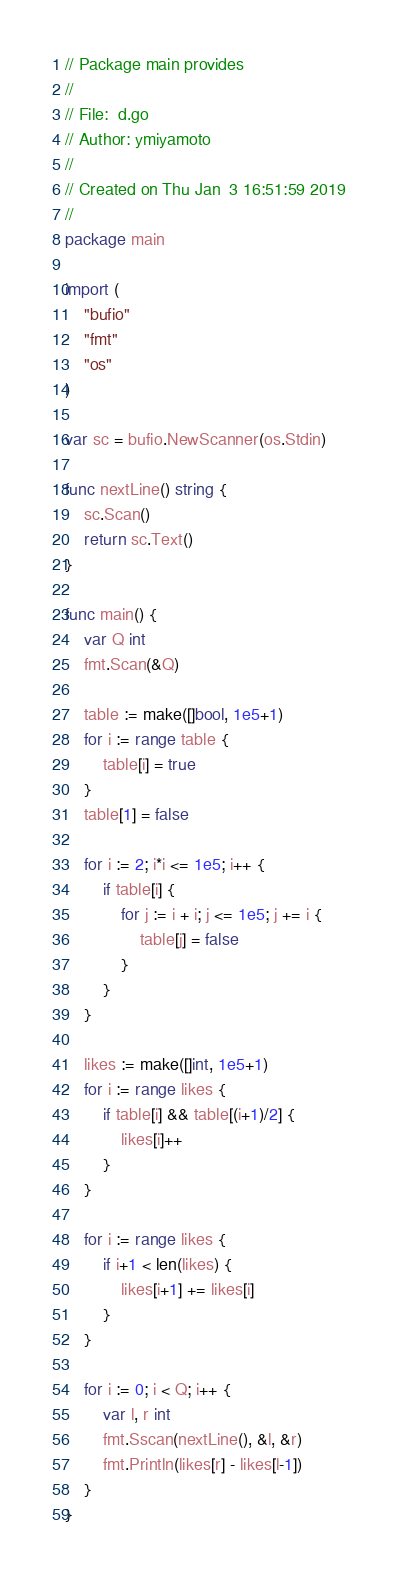<code> <loc_0><loc_0><loc_500><loc_500><_Go_>// Package main provides
//
// File:  d.go
// Author: ymiyamoto
//
// Created on Thu Jan  3 16:51:59 2019
//
package main

import (
	"bufio"
	"fmt"
	"os"
)

var sc = bufio.NewScanner(os.Stdin)

func nextLine() string {
	sc.Scan()
	return sc.Text()
}

func main() {
	var Q int
	fmt.Scan(&Q)

	table := make([]bool, 1e5+1)
	for i := range table {
		table[i] = true
	}
	table[1] = false

	for i := 2; i*i <= 1e5; i++ {
		if table[i] {
			for j := i + i; j <= 1e5; j += i {
				table[j] = false
			}
		}
	}

	likes := make([]int, 1e5+1)
	for i := range likes {
		if table[i] && table[(i+1)/2] {
			likes[i]++
		}
	}

	for i := range likes {
		if i+1 < len(likes) {
			likes[i+1] += likes[i]
		}
	}

	for i := 0; i < Q; i++ {
		var l, r int
		fmt.Sscan(nextLine(), &l, &r)
		fmt.Println(likes[r] - likes[l-1])
	}
}
</code> 